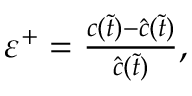Convert formula to latex. <formula><loc_0><loc_0><loc_500><loc_500>\begin{array} { r } { \varepsilon ^ { + } = \frac { c ( \tilde { t } ) - \hat { c } ( \tilde { t } ) } { \hat { c } ( \tilde { t } ) } , } \end{array}</formula> 